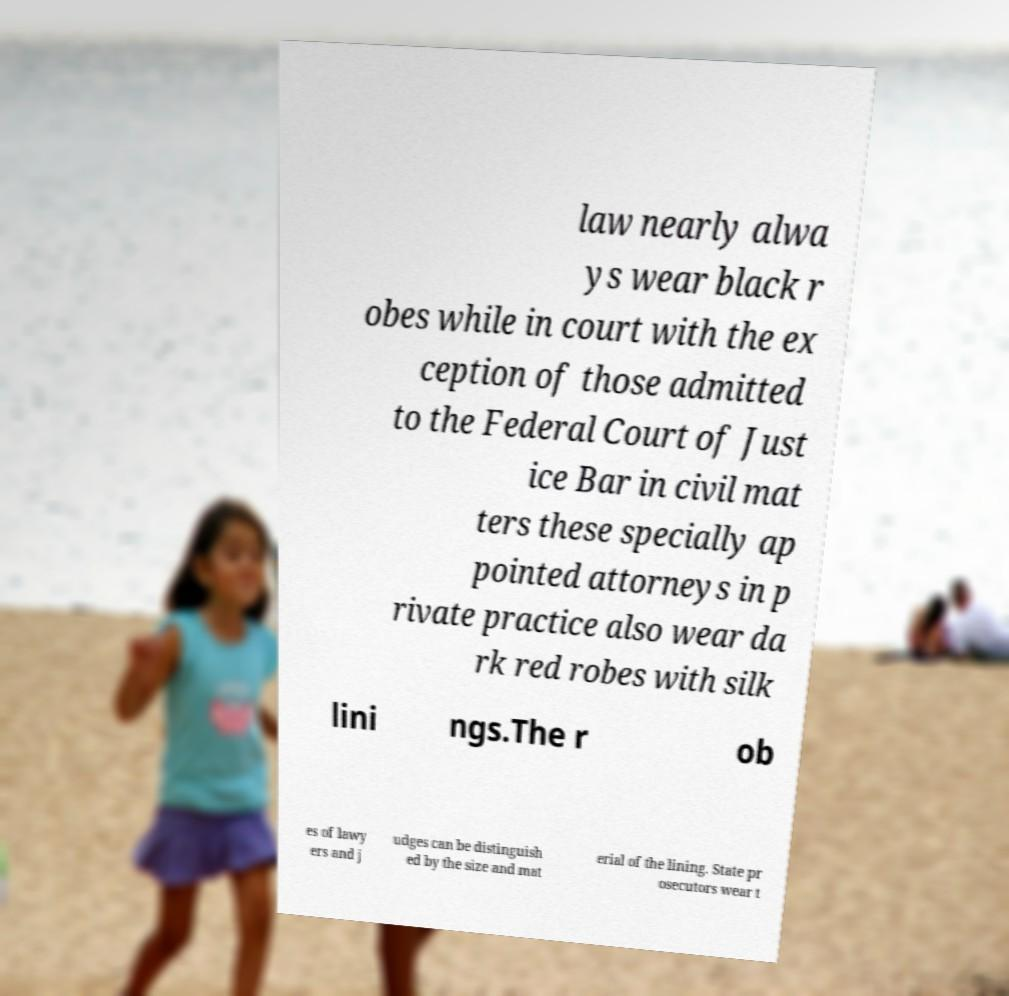Can you read and provide the text displayed in the image?This photo seems to have some interesting text. Can you extract and type it out for me? law nearly alwa ys wear black r obes while in court with the ex ception of those admitted to the Federal Court of Just ice Bar in civil mat ters these specially ap pointed attorneys in p rivate practice also wear da rk red robes with silk lini ngs.The r ob es of lawy ers and j udges can be distinguish ed by the size and mat erial of the lining. State pr osecutors wear t 